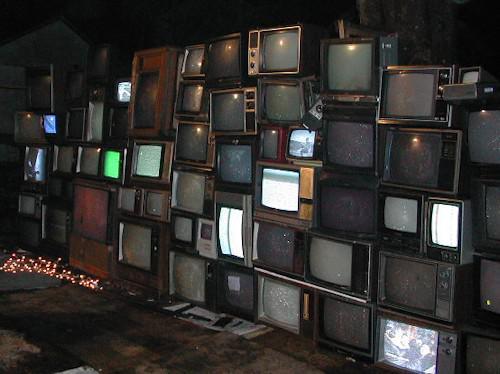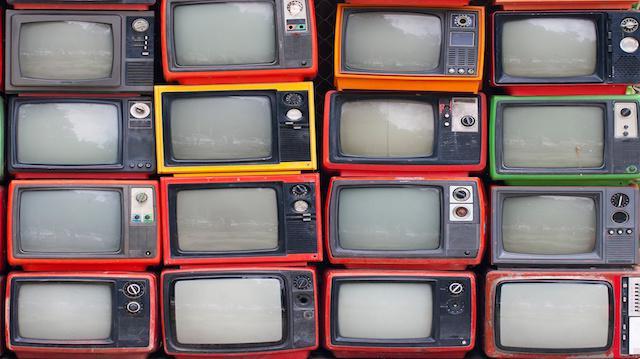The first image is the image on the left, the second image is the image on the right. Assess this claim about the two images: "All the TVs stacked in the right image have different scenes playing on the screens.". Correct or not? Answer yes or no. No. The first image is the image on the left, the second image is the image on the right. For the images displayed, is the sentence "The televisions in the image on the right are all turned on." factually correct? Answer yes or no. No. 